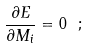<formula> <loc_0><loc_0><loc_500><loc_500>\frac { \partial E } { \partial M _ { i } } = 0 \text { } ;</formula> 